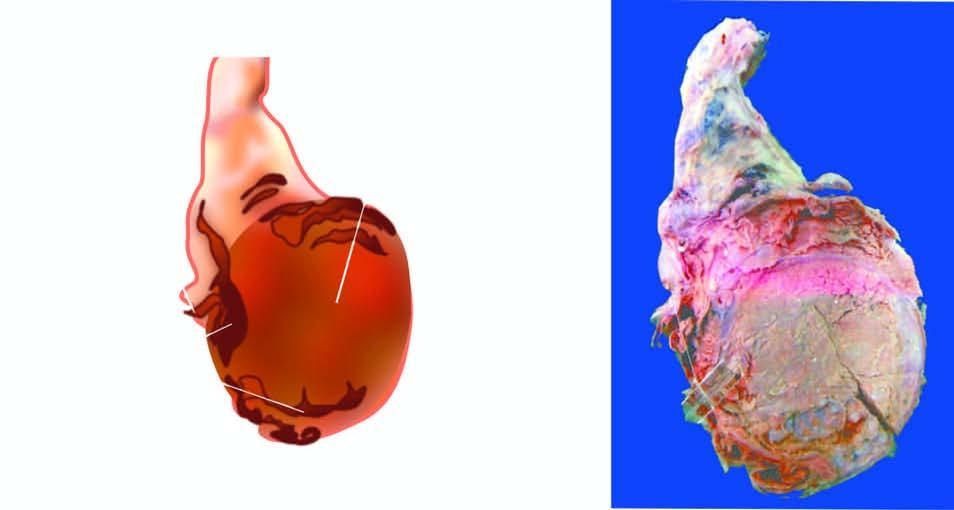s the testis enlarged and nodular distorting the testicular contour?
Answer the question using a single word or phrase. Yes 